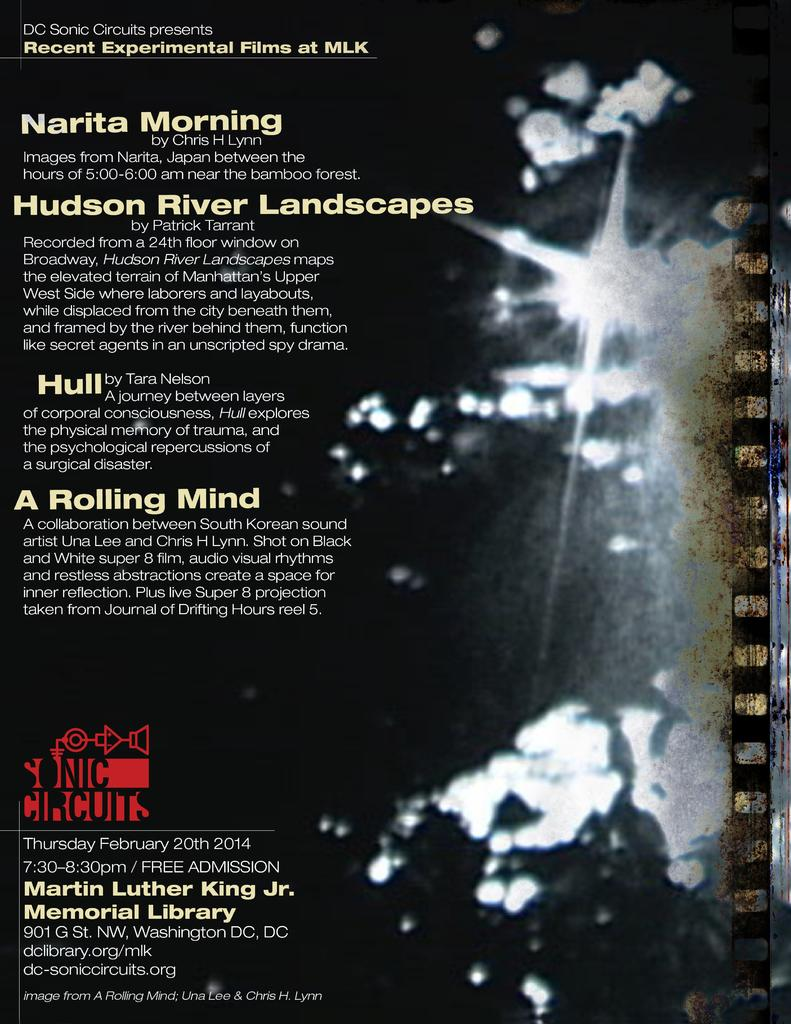What can be seen in the foreground of the image? There is text in the foreground of the image. On which side of the image is the text located? The text is on the left side of the image. How many toes are visible in the image? There are no toes visible in the image; it only contains text in the foreground. 